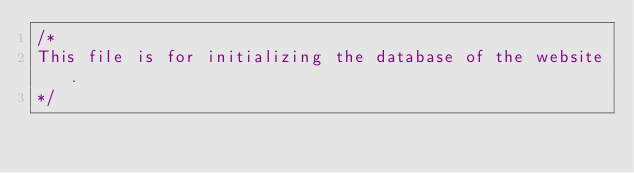<code> <loc_0><loc_0><loc_500><loc_500><_SQL_>/*
This file is for initializing the database of the website. 
*/
</code> 